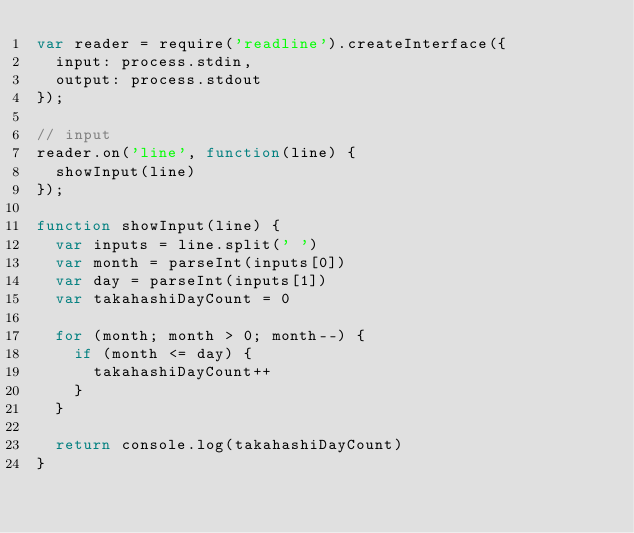Convert code to text. <code><loc_0><loc_0><loc_500><loc_500><_JavaScript_>var reader = require('readline').createInterface({
  input: process.stdin,
  output: process.stdout
});

// input
reader.on('line', function(line) {
  showInput(line)
});

function showInput(line) {
  var inputs = line.split(' ')
  var month = parseInt(inputs[0])
  var day = parseInt(inputs[1])
  var takahashiDayCount = 0

  for (month; month > 0; month--) {
    if (month <= day) {
      takahashiDayCount++
    }
  }

  return console.log(takahashiDayCount)
}</code> 